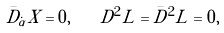Convert formula to latex. <formula><loc_0><loc_0><loc_500><loc_500>\bar { D } _ { \dot { \alpha } } X = 0 , \quad D ^ { 2 } L = \bar { D } ^ { 2 } L = 0 ,</formula> 